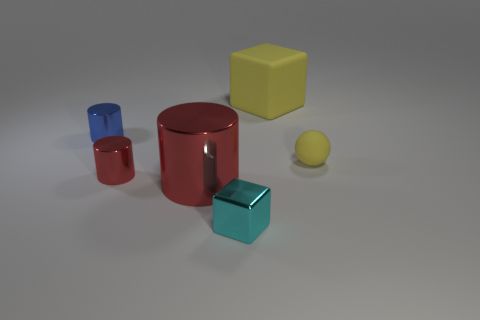What number of other objects are there of the same shape as the small yellow object?
Ensure brevity in your answer.  0. Do the red thing that is behind the big cylinder and the small yellow sphere have the same material?
Your answer should be compact. No. What number of objects are yellow rubber balls or cyan objects?
Offer a very short reply. 2. What size is the other red metallic object that is the same shape as the small red metallic object?
Offer a terse response. Large. The yellow cube is what size?
Make the answer very short. Large. Are there more matte spheres in front of the large yellow rubber thing than brown balls?
Keep it short and to the point. Yes. There is a small object on the right side of the large yellow matte block; is it the same color as the matte object that is on the left side of the sphere?
Your answer should be very brief. Yes. There is a large cube to the right of the tiny cylinder that is in front of the rubber object in front of the large yellow matte thing; what is it made of?
Give a very brief answer. Rubber. Is the number of small cubes greater than the number of big green shiny blocks?
Make the answer very short. Yes. Is there any other thing that has the same color as the matte cube?
Your answer should be very brief. Yes. 